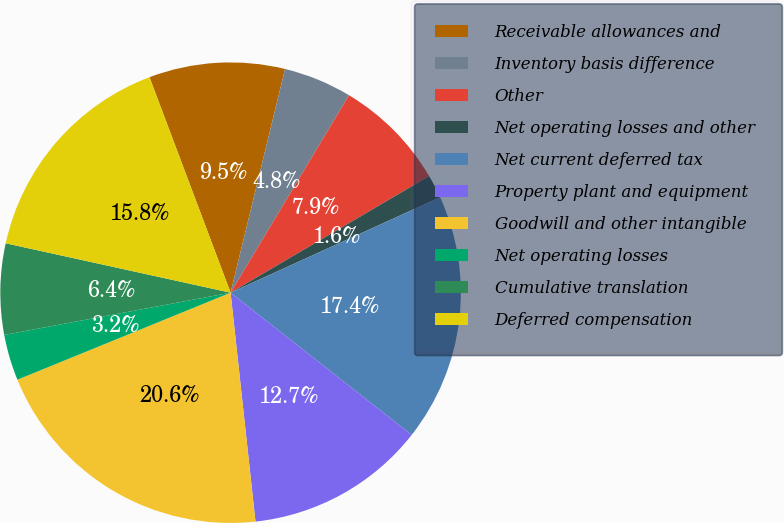<chart> <loc_0><loc_0><loc_500><loc_500><pie_chart><fcel>Receivable allowances and<fcel>Inventory basis difference<fcel>Other<fcel>Net operating losses and other<fcel>Net current deferred tax<fcel>Property plant and equipment<fcel>Goodwill and other intangible<fcel>Net operating losses<fcel>Cumulative translation<fcel>Deferred compensation<nl><fcel>9.53%<fcel>4.8%<fcel>7.95%<fcel>1.65%<fcel>17.4%<fcel>12.68%<fcel>20.56%<fcel>3.23%<fcel>6.38%<fcel>15.83%<nl></chart> 